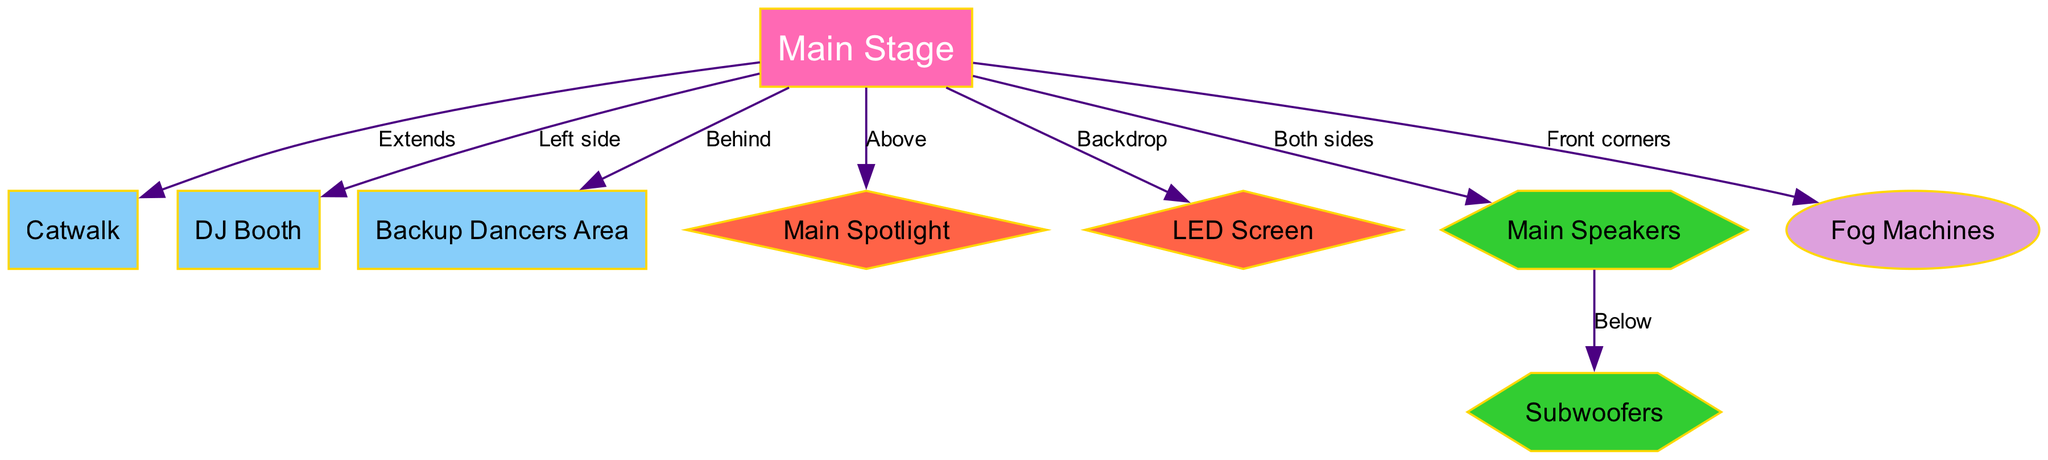What is the primary area where Teyana Taylor performs? The primary performance area is labeled as the "Main Stage" in the diagram.
Answer: Main Stage Where is the DJ Booth located in relation to the Main Stage? According to the diagram, the DJ Booth is located on the left side of the Main Stage.
Answer: Left side How many main sound equipment components are shown in the diagram? The diagram includes two main sound equipment components: Speakers and Subwoofers.
Answer: 2 What is placed above the Main Stage? The Main Spotlight is positioned directly above the Main Stage as indicated in the diagram.
Answer: Main Spotlight Where are the Fog Machines located? The Fog Machines are located at the front corners of the Main Stage.
Answer: Front corners Which area is situated behind the Main Stage? The area designated for Backup Dancers is located behind the Main Stage according to the edges in the diagram.
Answer: Backup Dancers Area What extends from the Main Stage? A Catwalk extends from the front of the Main Stage as specified in the diagram.
Answer: Catwalk Which sound equipment component is positioned below the Main Speakers? The Subwoofers are situated directly below the Main Speakers, as indicated by the connection in the diagram.
Answer: Subwoofers What is the color theme for the nodes in this diagram? The color theme features vibrant colors like pink for the Main Stage, blue for specific areas, and various colors for sound and lighting elements.
Answer: Vibrant colors 